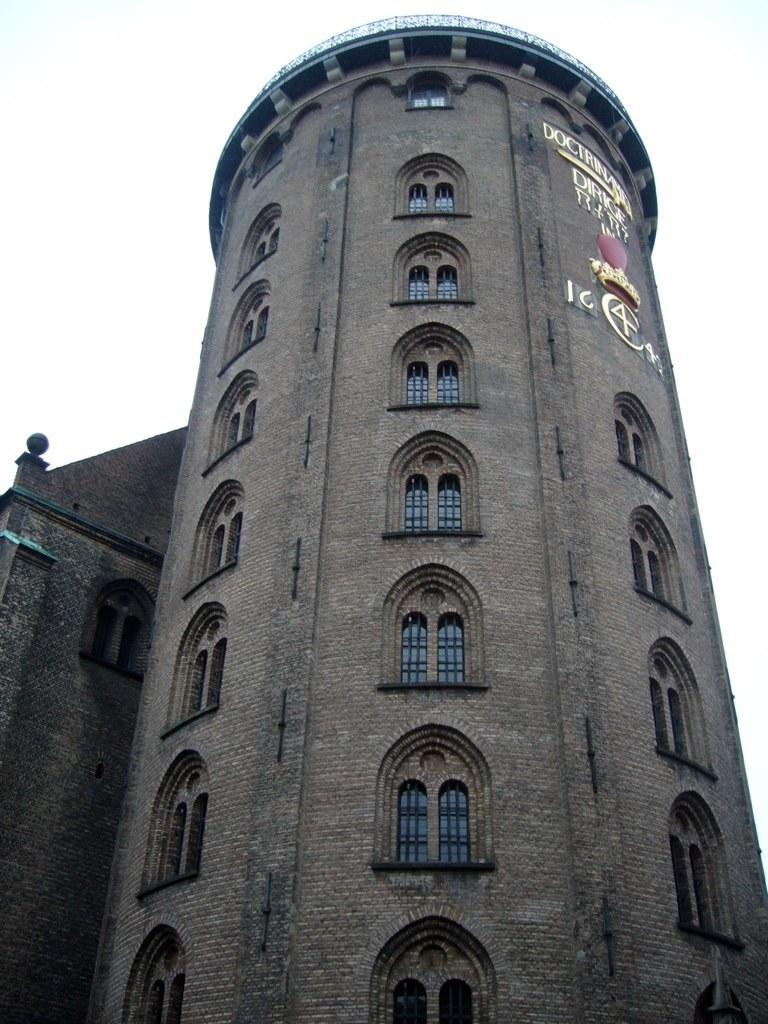What is the main focus of the image? The center of the image contains the sky and clouds. Are there any structures in the image? Yes, there is one building in the image. What can be observed about the building? The building has windows. What else can be seen in the image besides the sky, clouds, and building? There are other objects in the image. Is there any text visible on the building? Yes, there is text visible on the building. Can you see any cheese being grated on the toes in the image? There is no cheese or toes present in the image. 